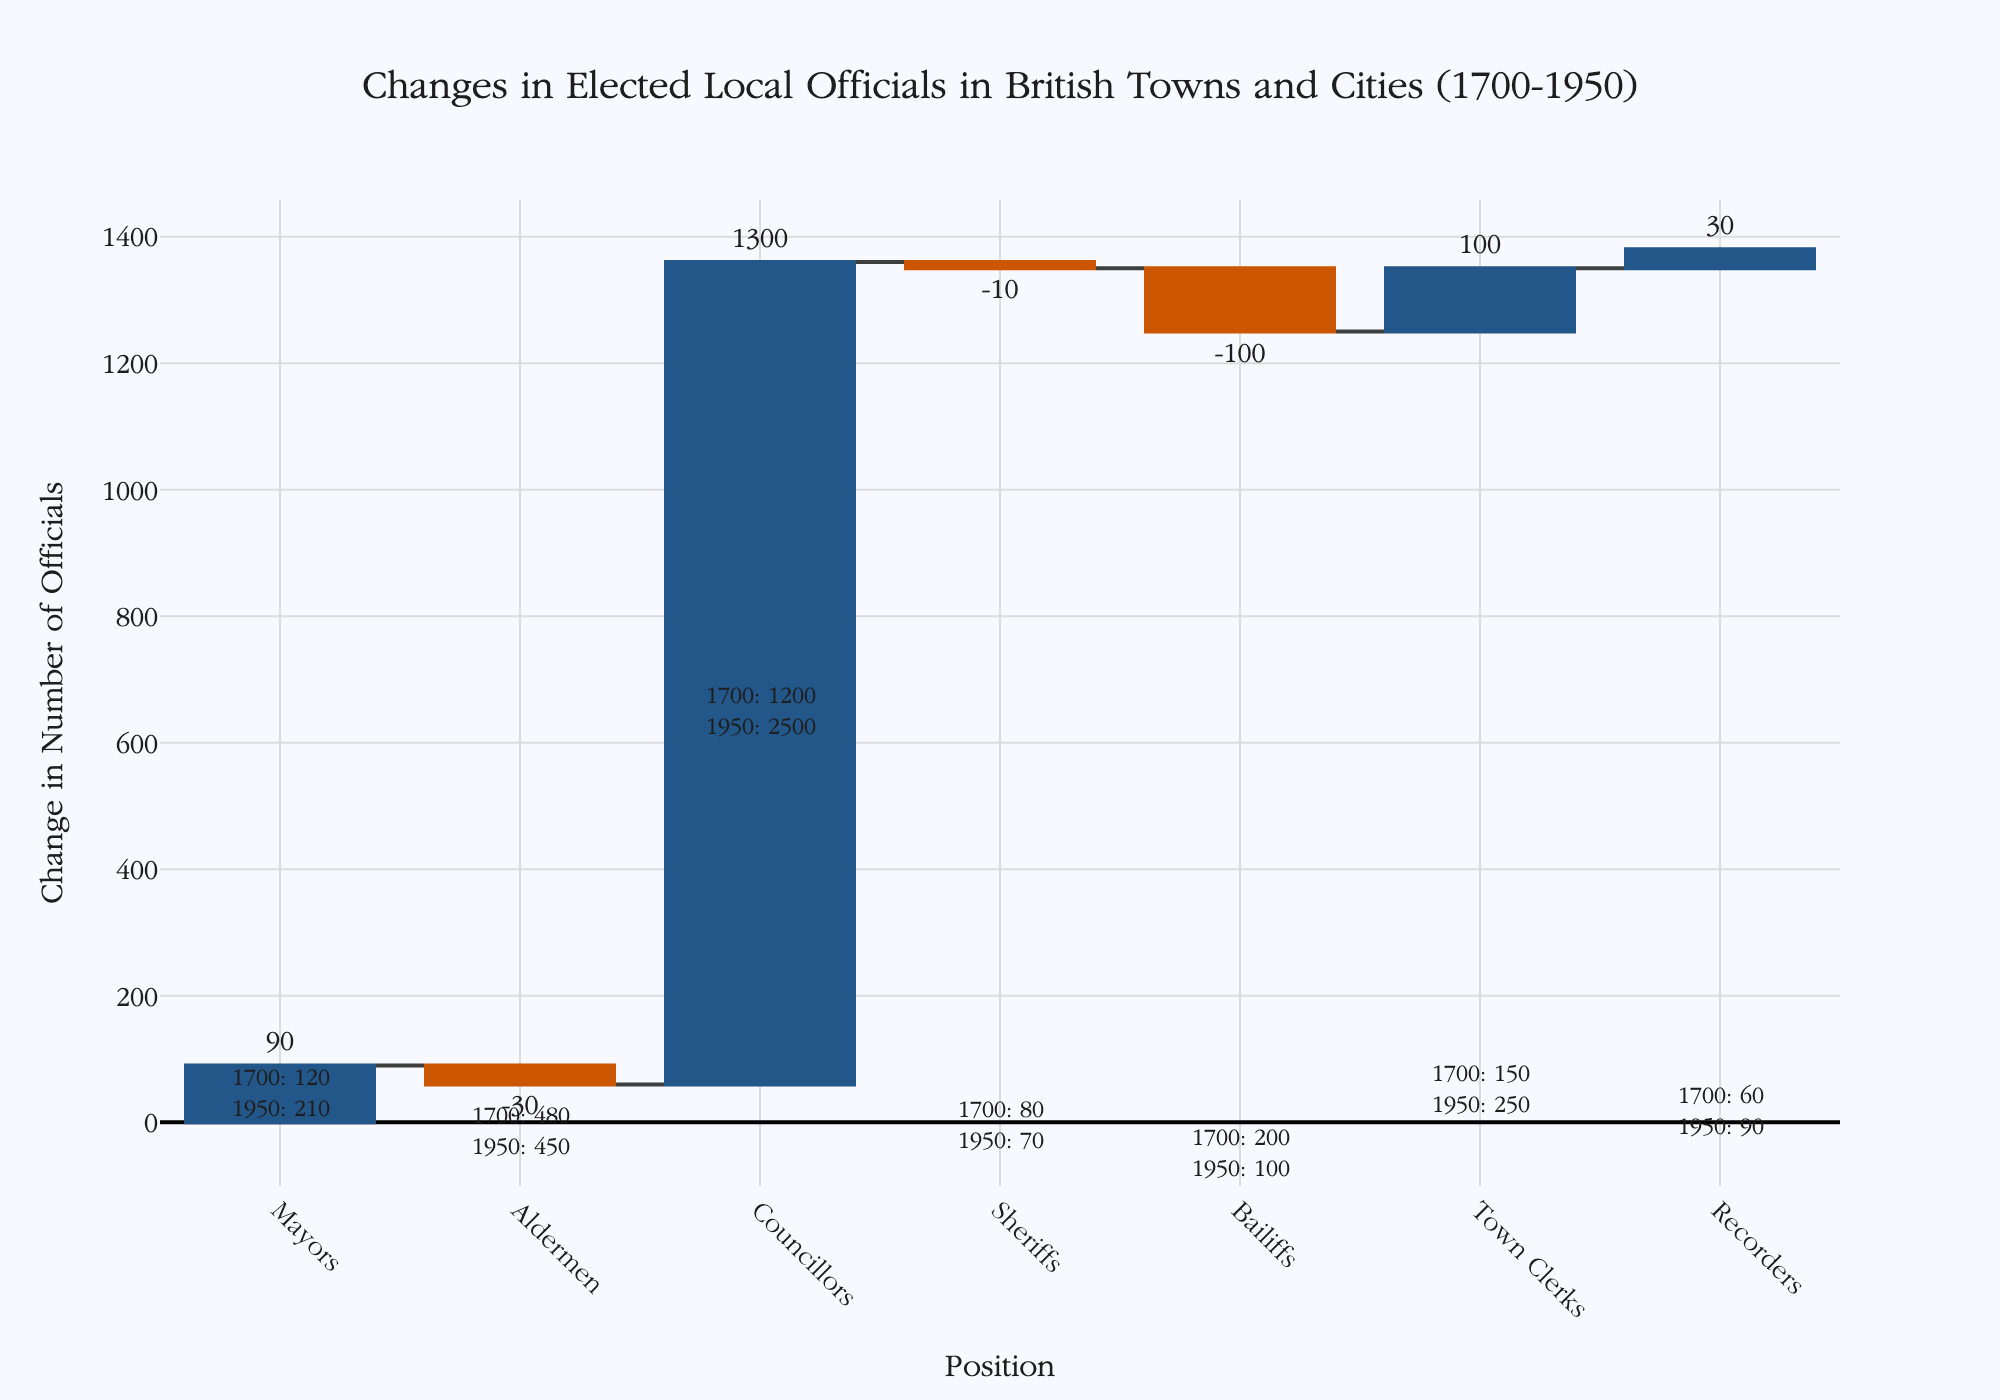What's the title of the figure? The title is located at the top of the figure. It reads, "Changes in Elected Local Officials in British Towns and Cities (1700-1950)".
Answer: Changes in Elected Local Officials in British Towns and Cities (1700-1950) How many types of positions are shown in the figure? By looking at the x-axis, you can count the number of distinct position labels displayed. There are 7 positions: Mayors, Aldermen, Councillors, Sheriffs, Bailiffs, Town Clerks, and Recorders.
Answer: 7 Which position saw the greatest increase in the number of officials between 1700 and 1950? Observe the bars and their corresponding changes. Councillors have the tallest increasing bar, indicating the greatest rise. This can also be confirmed by the text above the bar, which shows an increase of +1300.
Answer: Councillors Which position experienced a decrease in the number of officials from 1700 to 1950? Observe the bars colored for a decrease. The positions with decreasing numbers are Aldermen, Sheriffs, and Bailiffs.
Answer: Aldermen, Sheriffs, Bailiffs What was the total number of Councillors in 1950? Look for the annotation above the Councillors bar. It states the numbers for 1700 and 1950. For Councillors, it is 2500 in 1950.
Answer: 2500 What is the net change in the number of Mayors between 1700 and 1950? Check the size and text of the bar for Mayors. The number has increased by 90 from 1700 to 1950.
Answer: +90 By how much did the number of Bailiffs decrease from 1700 to 1950? Look at the bar for Bailiffs. It shows the change from 1700 to 1950, with a decrease of -100.
Answer: -100 What is the combined increase in the number of Mayors and Town Clerks from 1700 to 1950? Add the individual increases for Mayors (+90) and Town Clerks (+100), as shown by the bar annotations. Combined, it is 90 + 100 = 190.
Answer: 190 Which position changed the least in the number of officials from 1700 to 1950? Identify the bar with the smallest change, either positive or negative. Recorders show the smallest change with an increase of +30.
Answer: Recorders What was the change for Aldermen from 1700 to 1950? Observe the bar for Aldermen, which shows a decrease. The annotation indicates a change of -30.
Answer: -30 